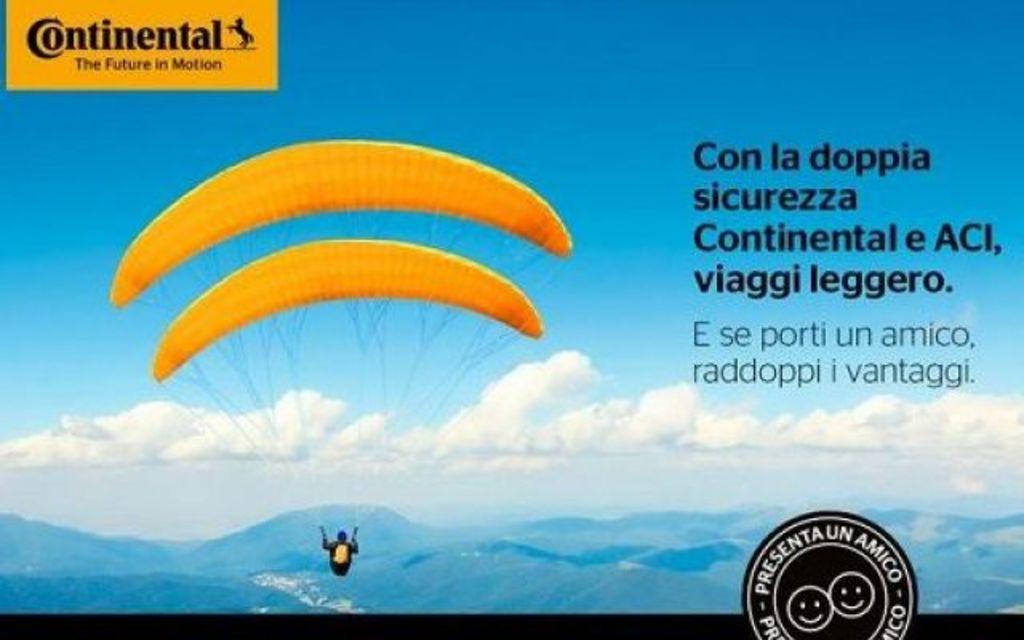Could you give a brief overview of what you see in this image? In this image a person, parachute, logo, text, mountains and the sky. This image looks like a photo frame. 